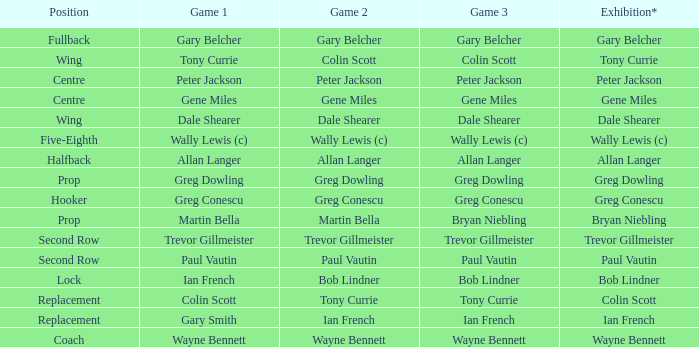In which game is bob lindner involved in the same way as in game 2? Ian French. 